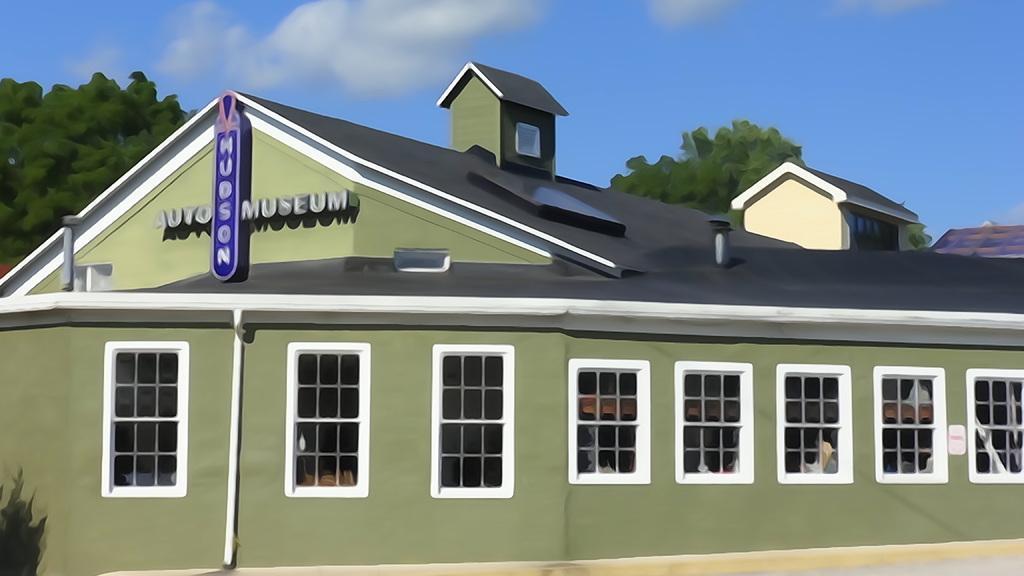Describe this image in one or two sentences. Here in this picture we can see an animated house present over there and we can see windows on it and behind it we can see trees and we can see clouds in sky. 